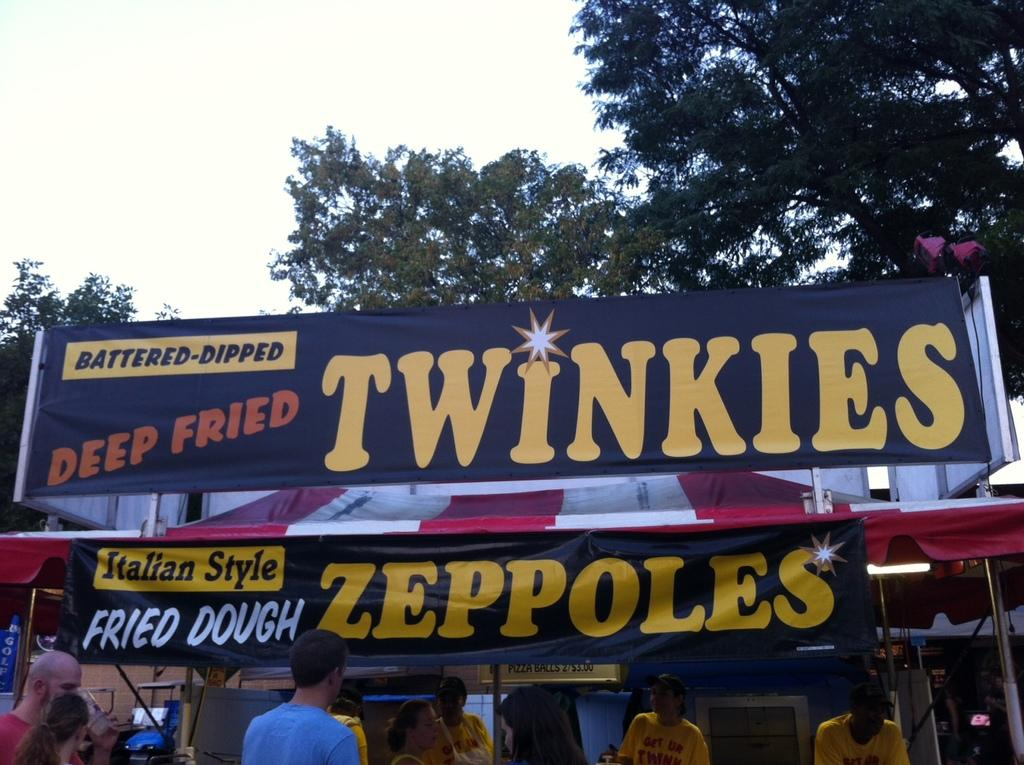What is located in the foreground of the image? There is a crowd and a food truck in the foreground of the image. What can be seen on the board in the foreground of the image? Unfortunately, the facts provided do not give information about what is on the board. What is the setting of the image? The image was taken during the day, and there are trees and the sky visible in the background. How many boys are sitting on the chairs in the office in the image? There is no office or chairs present in the image. What type of chairs are used in the office in the image? There is no office or chairs present in the image, so it is not possible to answer this question. 